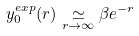<formula> <loc_0><loc_0><loc_500><loc_500>y _ { 0 } ^ { e x p } ( r ) \underset { r \rightarrow \infty } { \simeq } \beta e ^ { - r }</formula> 